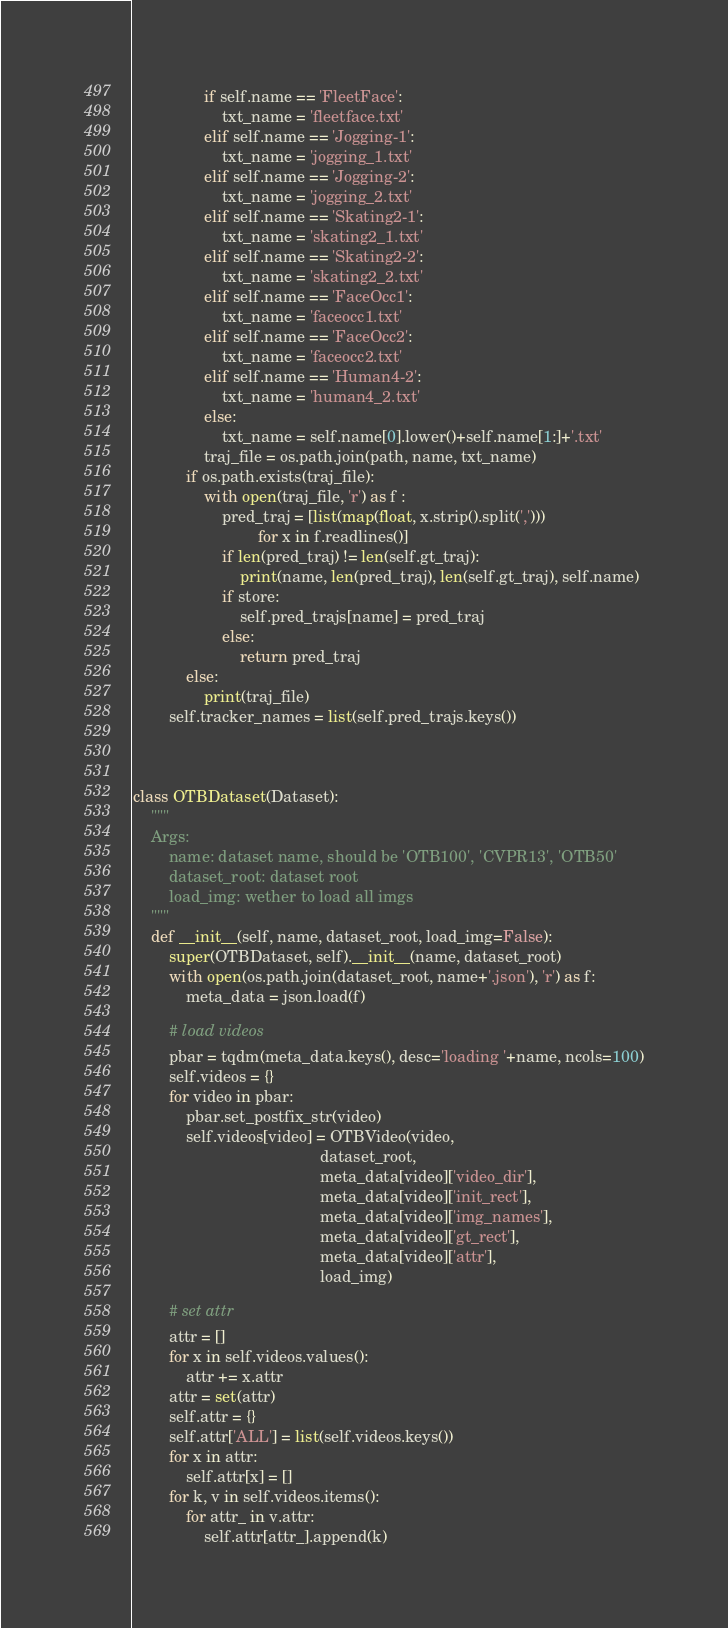Convert code to text. <code><loc_0><loc_0><loc_500><loc_500><_Python_>                if self.name == 'FleetFace':
                    txt_name = 'fleetface.txt'
                elif self.name == 'Jogging-1':
                    txt_name = 'jogging_1.txt'
                elif self.name == 'Jogging-2':
                    txt_name = 'jogging_2.txt'
                elif self.name == 'Skating2-1':
                    txt_name = 'skating2_1.txt'
                elif self.name == 'Skating2-2':
                    txt_name = 'skating2_2.txt'
                elif self.name == 'FaceOcc1':
                    txt_name = 'faceocc1.txt'
                elif self.name == 'FaceOcc2':
                    txt_name = 'faceocc2.txt'
                elif self.name == 'Human4-2':
                    txt_name = 'human4_2.txt'
                else:
                    txt_name = self.name[0].lower()+self.name[1:]+'.txt'
                traj_file = os.path.join(path, name, txt_name)
            if os.path.exists(traj_file):
                with open(traj_file, 'r') as f :
                    pred_traj = [list(map(float, x.strip().split(',')))
                            for x in f.readlines()]
                    if len(pred_traj) != len(self.gt_traj):
                        print(name, len(pred_traj), len(self.gt_traj), self.name)
                    if store:
                        self.pred_trajs[name] = pred_traj
                    else:
                        return pred_traj
            else:
                print(traj_file)
        self.tracker_names = list(self.pred_trajs.keys())



class OTBDataset(Dataset):
    """
    Args:
        name: dataset name, should be 'OTB100', 'CVPR13', 'OTB50'
        dataset_root: dataset root
        load_img: wether to load all imgs
    """
    def __init__(self, name, dataset_root, load_img=False):
        super(OTBDataset, self).__init__(name, dataset_root)
        with open(os.path.join(dataset_root, name+'.json'), 'r') as f:
            meta_data = json.load(f)

        # load videos
        pbar = tqdm(meta_data.keys(), desc='loading '+name, ncols=100)
        self.videos = {}
        for video in pbar:
            pbar.set_postfix_str(video)
            self.videos[video] = OTBVideo(video,
                                          dataset_root,
                                          meta_data[video]['video_dir'],
                                          meta_data[video]['init_rect'],
                                          meta_data[video]['img_names'],
                                          meta_data[video]['gt_rect'],
                                          meta_data[video]['attr'],
                                          load_img)

        # set attr
        attr = []
        for x in self.videos.values():
            attr += x.attr
        attr = set(attr)
        self.attr = {}
        self.attr['ALL'] = list(self.videos.keys())
        for x in attr:
            self.attr[x] = []
        for k, v in self.videos.items():
            for attr_ in v.attr:
                self.attr[attr_].append(k)
</code> 